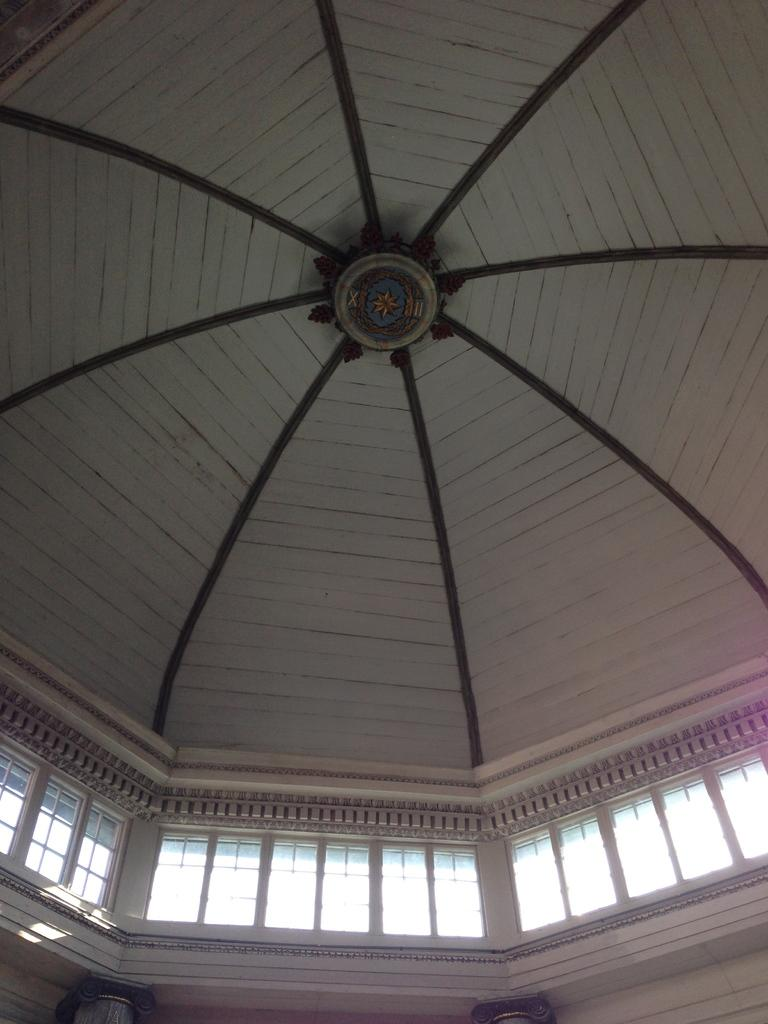What type of location is depicted in the image? The image is an inside view of a building. What architectural feature can be seen in the building? There are windows in the building. What can be found on the ceiling of the building? There are decorations on the ceiling. What type of bait is used to attract visitors to the building in the image? There is no mention of bait or attracting visitors in the image; it simply shows an inside view of a building with windows and decorations on the ceiling. 